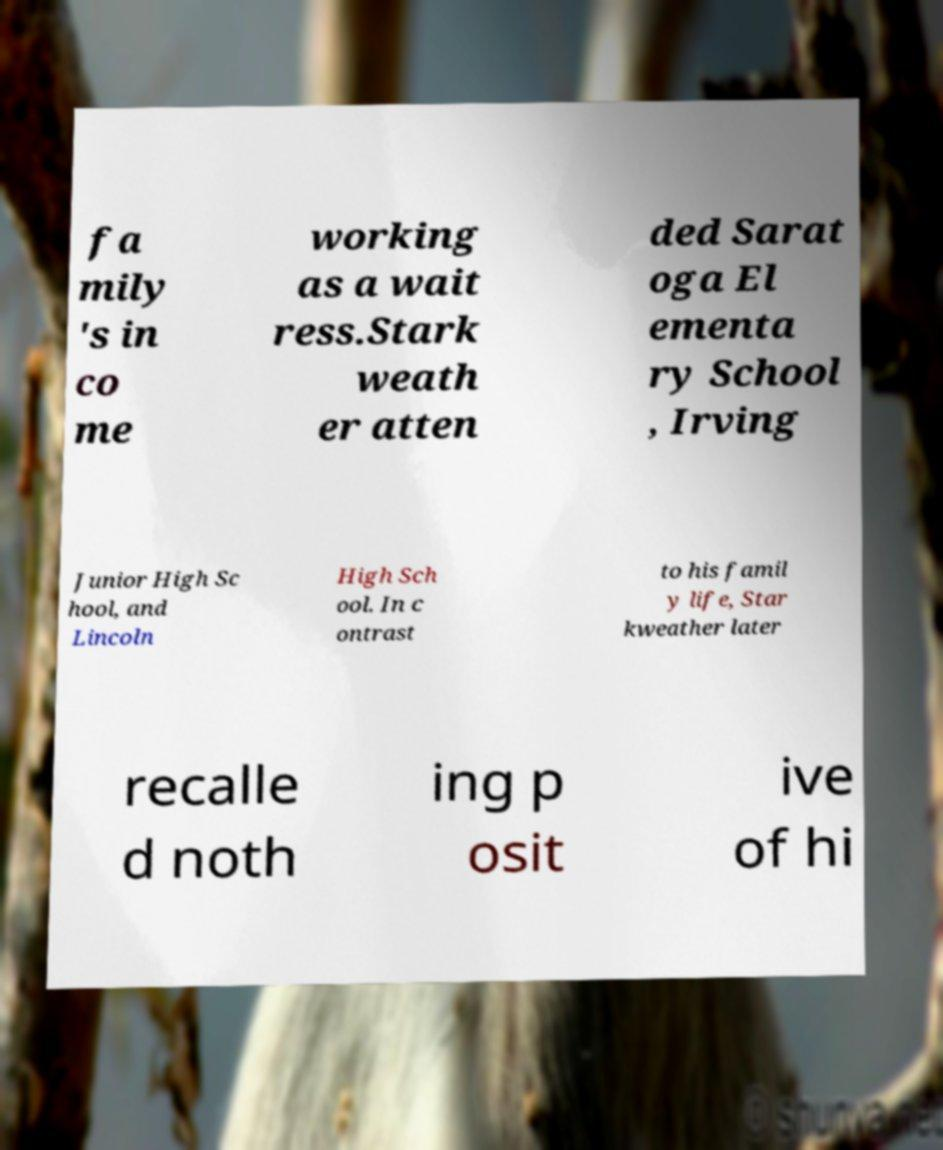Could you assist in decoding the text presented in this image and type it out clearly? fa mily 's in co me working as a wait ress.Stark weath er atten ded Sarat oga El ementa ry School , Irving Junior High Sc hool, and Lincoln High Sch ool. In c ontrast to his famil y life, Star kweather later recalle d noth ing p osit ive of hi 